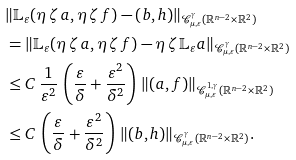Convert formula to latex. <formula><loc_0><loc_0><loc_500><loc_500>& \| \mathbb { L } _ { \varepsilon } ( \eta \, \zeta \, a , \eta \, \zeta \, f ) - ( b , h ) \| _ { \mathcal { C } _ { \mu , \varepsilon } ^ { \gamma } ( \mathbb { R } ^ { n - 2 } \times \mathbb { R } ^ { 2 } ) } \\ & = \| \mathbb { L } _ { \varepsilon } ( \eta \, \zeta \, a , \eta \, \zeta \, f ) - \eta \, \zeta \, \mathbb { L } _ { \varepsilon } a \| _ { \mathcal { C } _ { \mu , \varepsilon } ^ { \gamma } ( \mathbb { R } ^ { n - 2 } \times \mathbb { R } ^ { 2 } ) } \\ & \leq C \, \frac { 1 } { \varepsilon ^ { 2 } } \, \left ( \frac { \varepsilon } { \delta } + \frac { \varepsilon ^ { 2 } } { \delta ^ { 2 } } \right ) \, \| ( a , f ) \| _ { \mathcal { C } _ { \mu , \varepsilon } ^ { 1 , \gamma } ( \mathbb { R } ^ { n - 2 } \times \mathbb { R } ^ { 2 } ) } \\ & \leq C \, \left ( \frac { \varepsilon } { \delta } + \frac { \varepsilon ^ { 2 } } { \delta ^ { 2 } } \right ) \, \| ( b , h ) \| _ { \mathcal { C } _ { \mu , \varepsilon } ^ { \gamma } ( \mathbb { R } ^ { n - 2 } \times \mathbb { R } ^ { 2 } ) } .</formula> 